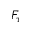Convert formula to latex. <formula><loc_0><loc_0><loc_500><loc_500>F _ { \tau }</formula> 